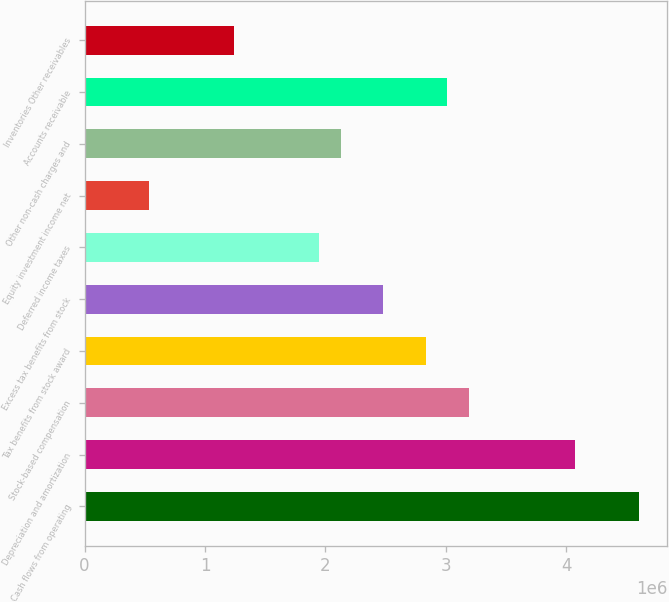Convert chart to OTSL. <chart><loc_0><loc_0><loc_500><loc_500><bar_chart><fcel>Cash flows from operating<fcel>Depreciation and amortization<fcel>Stock-based compensation<fcel>Tax benefits from stock award<fcel>Excess tax benefits from stock<fcel>Deferred income taxes<fcel>Equity investment income net<fcel>Other non-cash charges and<fcel>Accounts receivable<fcel>Inventories Other receivables<nl><fcel>4.60902e+06<fcel>4.07733e+06<fcel>3.19118e+06<fcel>2.83672e+06<fcel>2.48226e+06<fcel>1.95057e+06<fcel>532730<fcel>2.1278e+06<fcel>3.01395e+06<fcel>1.24165e+06<nl></chart> 